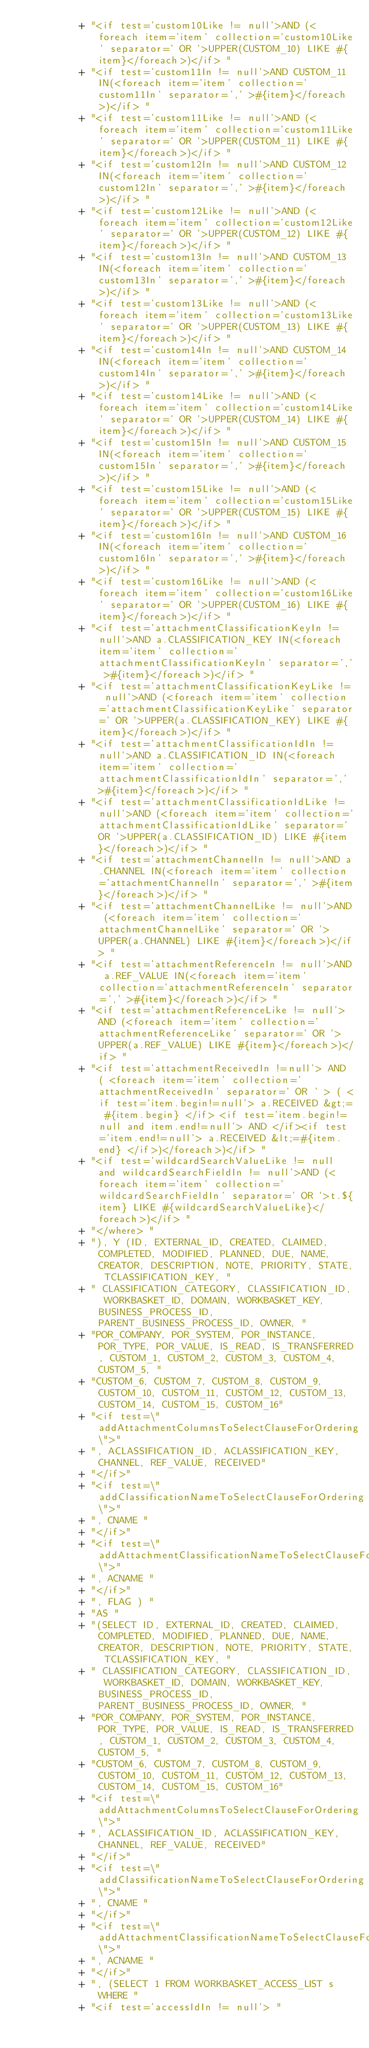Convert code to text. <code><loc_0><loc_0><loc_500><loc_500><_Java_>          + "<if test='custom10Like != null'>AND (<foreach item='item' collection='custom10Like' separator=' OR '>UPPER(CUSTOM_10) LIKE #{item}</foreach>)</if> "
          + "<if test='custom11In != null'>AND CUSTOM_11 IN(<foreach item='item' collection='custom11In' separator=',' >#{item}</foreach>)</if> "
          + "<if test='custom11Like != null'>AND (<foreach item='item' collection='custom11Like' separator=' OR '>UPPER(CUSTOM_11) LIKE #{item}</foreach>)</if> "
          + "<if test='custom12In != null'>AND CUSTOM_12 IN(<foreach item='item' collection='custom12In' separator=',' >#{item}</foreach>)</if> "
          + "<if test='custom12Like != null'>AND (<foreach item='item' collection='custom12Like' separator=' OR '>UPPER(CUSTOM_12) LIKE #{item}</foreach>)</if> "
          + "<if test='custom13In != null'>AND CUSTOM_13 IN(<foreach item='item' collection='custom13In' separator=',' >#{item}</foreach>)</if> "
          + "<if test='custom13Like != null'>AND (<foreach item='item' collection='custom13Like' separator=' OR '>UPPER(CUSTOM_13) LIKE #{item}</foreach>)</if> "
          + "<if test='custom14In != null'>AND CUSTOM_14 IN(<foreach item='item' collection='custom14In' separator=',' >#{item}</foreach>)</if> "
          + "<if test='custom14Like != null'>AND (<foreach item='item' collection='custom14Like' separator=' OR '>UPPER(CUSTOM_14) LIKE #{item}</foreach>)</if> "
          + "<if test='custom15In != null'>AND CUSTOM_15 IN(<foreach item='item' collection='custom15In' separator=',' >#{item}</foreach>)</if> "
          + "<if test='custom15Like != null'>AND (<foreach item='item' collection='custom15Like' separator=' OR '>UPPER(CUSTOM_15) LIKE #{item}</foreach>)</if> "
          + "<if test='custom16In != null'>AND CUSTOM_16 IN(<foreach item='item' collection='custom16In' separator=',' >#{item}</foreach>)</if> "
          + "<if test='custom16Like != null'>AND (<foreach item='item' collection='custom16Like' separator=' OR '>UPPER(CUSTOM_16) LIKE #{item}</foreach>)</if> "
          + "<if test='attachmentClassificationKeyIn != null'>AND a.CLASSIFICATION_KEY IN(<foreach item='item' collection='attachmentClassificationKeyIn' separator=',' >#{item}</foreach>)</if> "
          + "<if test='attachmentClassificationKeyLike != null'>AND (<foreach item='item' collection='attachmentClassificationKeyLike' separator=' OR '>UPPER(a.CLASSIFICATION_KEY) LIKE #{item}</foreach>)</if> "
          + "<if test='attachmentClassificationIdIn != null'>AND a.CLASSIFICATION_ID IN(<foreach item='item' collection='attachmentClassificationIdIn' separator=',' >#{item}</foreach>)</if> "
          + "<if test='attachmentClassificationIdLike != null'>AND (<foreach item='item' collection='attachmentClassificationIdLike' separator=' OR '>UPPER(a.CLASSIFICATION_ID) LIKE #{item}</foreach>)</if> "
          + "<if test='attachmentChannelIn != null'>AND a.CHANNEL IN(<foreach item='item' collection='attachmentChannelIn' separator=',' >#{item}</foreach>)</if> "
          + "<if test='attachmentChannelLike != null'>AND (<foreach item='item' collection='attachmentChannelLike' separator=' OR '>UPPER(a.CHANNEL) LIKE #{item}</foreach>)</if> "
          + "<if test='attachmentReferenceIn != null'>AND a.REF_VALUE IN(<foreach item='item' collection='attachmentReferenceIn' separator=',' >#{item}</foreach>)</if> "
          + "<if test='attachmentReferenceLike != null'>AND (<foreach item='item' collection='attachmentReferenceLike' separator=' OR '>UPPER(a.REF_VALUE) LIKE #{item}</foreach>)</if> "
          + "<if test='attachmentReceivedIn !=null'> AND ( <foreach item='item' collection='attachmentReceivedIn' separator=' OR ' > ( <if test='item.begin!=null'> a.RECEIVED &gt;= #{item.begin} </if> <if test='item.begin!=null and item.end!=null'> AND </if><if test='item.end!=null'> a.RECEIVED &lt;=#{item.end} </if>)</foreach>)</if> "
          + "<if test='wildcardSearchValueLike != null and wildcardSearchFieldIn != null'>AND (<foreach item='item' collection='wildcardSearchFieldIn' separator=' OR '>t.${item} LIKE #{wildcardSearchValueLike}</foreach>)</if> "
          + "</where> "
          + "), Y (ID, EXTERNAL_ID, CREATED, CLAIMED, COMPLETED, MODIFIED, PLANNED, DUE, NAME, CREATOR, DESCRIPTION, NOTE, PRIORITY, STATE, TCLASSIFICATION_KEY, "
          + " CLASSIFICATION_CATEGORY, CLASSIFICATION_ID, WORKBASKET_ID, DOMAIN, WORKBASKET_KEY, BUSINESS_PROCESS_ID, PARENT_BUSINESS_PROCESS_ID, OWNER, "
          + "POR_COMPANY, POR_SYSTEM, POR_INSTANCE, POR_TYPE, POR_VALUE, IS_READ, IS_TRANSFERRED, CUSTOM_1, CUSTOM_2, CUSTOM_3, CUSTOM_4, CUSTOM_5, "
          + "CUSTOM_6, CUSTOM_7, CUSTOM_8, CUSTOM_9, CUSTOM_10, CUSTOM_11, CUSTOM_12, CUSTOM_13, CUSTOM_14, CUSTOM_15, CUSTOM_16"
          + "<if test=\"addAttachmentColumnsToSelectClauseForOrdering\">"
          + ", ACLASSIFICATION_ID, ACLASSIFICATION_KEY, CHANNEL, REF_VALUE, RECEIVED"
          + "</if>"
          + "<if test=\"addClassificationNameToSelectClauseForOrdering\">"
          + ", CNAME "
          + "</if>"
          + "<if test=\"addAttachmentClassificationNameToSelectClauseForOrdering\">"
          + ", ACNAME "
          + "</if>"
          + ", FLAG ) "
          + "AS "
          + "(SELECT ID, EXTERNAL_ID, CREATED, CLAIMED, COMPLETED, MODIFIED, PLANNED, DUE, NAME, CREATOR, DESCRIPTION, NOTE, PRIORITY, STATE, TCLASSIFICATION_KEY, "
          + " CLASSIFICATION_CATEGORY, CLASSIFICATION_ID, WORKBASKET_ID, DOMAIN, WORKBASKET_KEY, BUSINESS_PROCESS_ID, PARENT_BUSINESS_PROCESS_ID, OWNER, "
          + "POR_COMPANY, POR_SYSTEM, POR_INSTANCE, POR_TYPE, POR_VALUE, IS_READ, IS_TRANSFERRED, CUSTOM_1, CUSTOM_2, CUSTOM_3, CUSTOM_4, CUSTOM_5, "
          + "CUSTOM_6, CUSTOM_7, CUSTOM_8, CUSTOM_9, CUSTOM_10, CUSTOM_11, CUSTOM_12, CUSTOM_13, CUSTOM_14, CUSTOM_15, CUSTOM_16"
          + "<if test=\"addAttachmentColumnsToSelectClauseForOrdering\">"
          + ", ACLASSIFICATION_ID, ACLASSIFICATION_KEY, CHANNEL, REF_VALUE, RECEIVED"
          + "</if>"
          + "<if test=\"addClassificationNameToSelectClauseForOrdering\">"
          + ", CNAME "
          + "</if>"
          + "<if test=\"addAttachmentClassificationNameToSelectClauseForOrdering\">"
          + ", ACNAME "
          + "</if>"
          + ", (SELECT 1 FROM WORKBASKET_ACCESS_LIST s WHERE "
          + "<if test='accessIdIn != null'> "</code> 